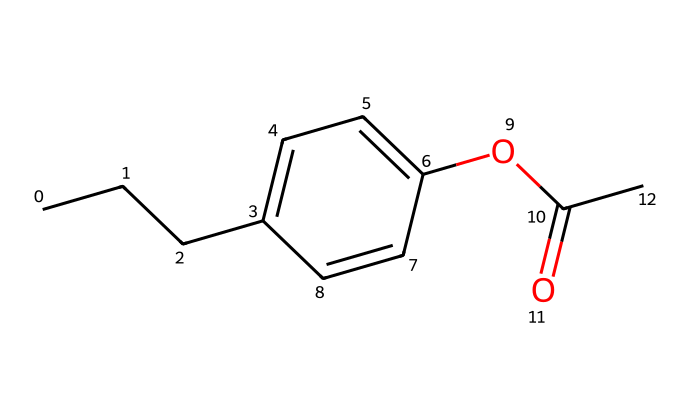What is the name of this chemical? The molecule represented in the SMILES notation is propylparaben, which is indicated by the presence of the propyl group and the paraben structure, as inferred from its functional groups.
Answer: propylparaben How many carbon atoms are present in propylparaben? By examining the SMILES representation, we can count the carbon atoms: there are 10 carbon atoms in total, including those in the propyl group and the aromatic ring.
Answer: 10 What functional group is present in this chemical? The presence of the ester group (indicated by the "OC(=O)" part of the SMILES) signifies the functional group characteristic of propylparaben, which is a derivative of p-hydroxybenzoic acid.
Answer: ester What type of compound is propylparaben classified as? Propylparaben is classified as a preservative. This classification is based on its use in food and personal care products to prevent microbial growth, stemming from its chemical structure that disrupts microbial cell function.
Answer: preservative How many double bonds are in the structure of propylparaben? The SMILES notation includes two double bonds, indicated by the "=" symbols within the aromatic ring, contributing to its conjugated system.
Answer: 2 What is the main application of propylparaben? Propylparaben is primarily used as a preservative in processed foods and toiletries, which helps to extend shelf life and maintain product integrity against microbial contamination.
Answer: preservative in foods and toiletries 